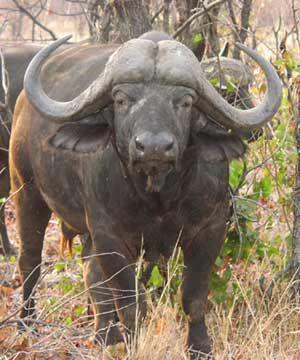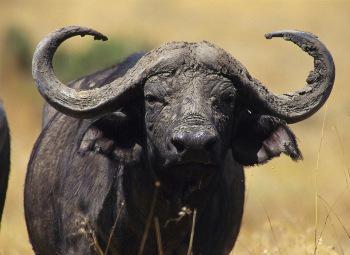The first image is the image on the left, the second image is the image on the right. Given the left and right images, does the statement "Each image contains one water buffalo in the foreground who is looking directly ahead at the camera." hold true? Answer yes or no. Yes. The first image is the image on the left, the second image is the image on the right. Analyze the images presented: Is the assertion "The left and right image contains the same number of long horned bull looking forward." valid? Answer yes or no. Yes. 